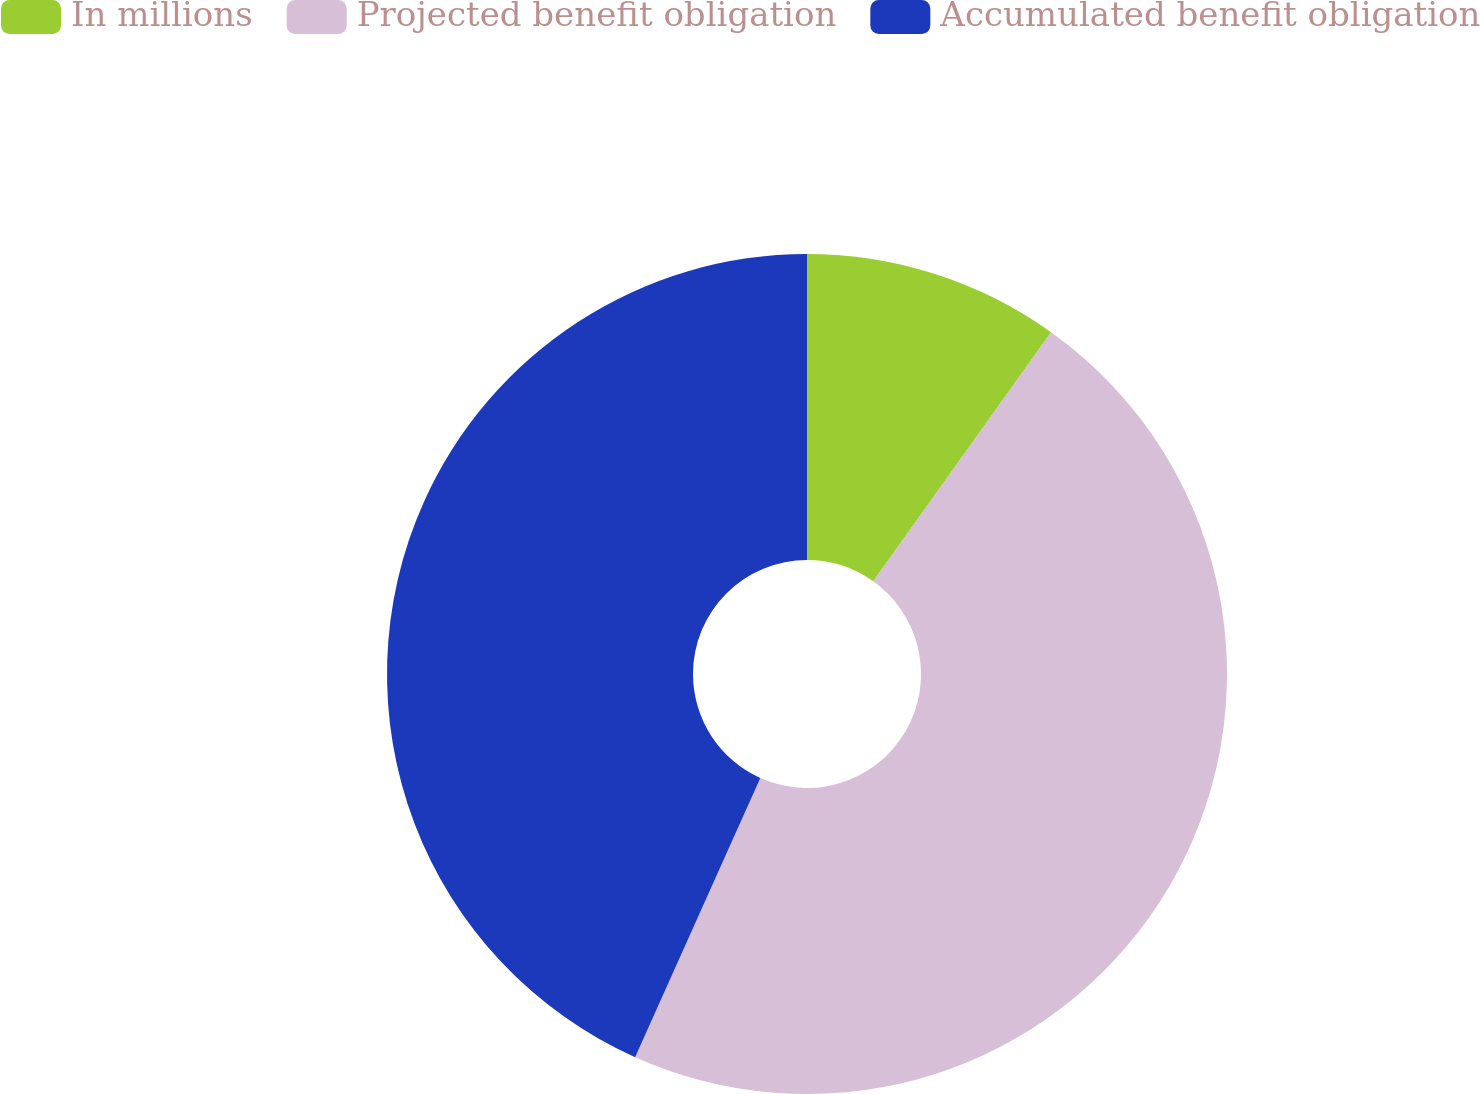<chart> <loc_0><loc_0><loc_500><loc_500><pie_chart><fcel>In millions<fcel>Projected benefit obligation<fcel>Accumulated benefit obligation<nl><fcel>9.87%<fcel>46.84%<fcel>43.29%<nl></chart> 